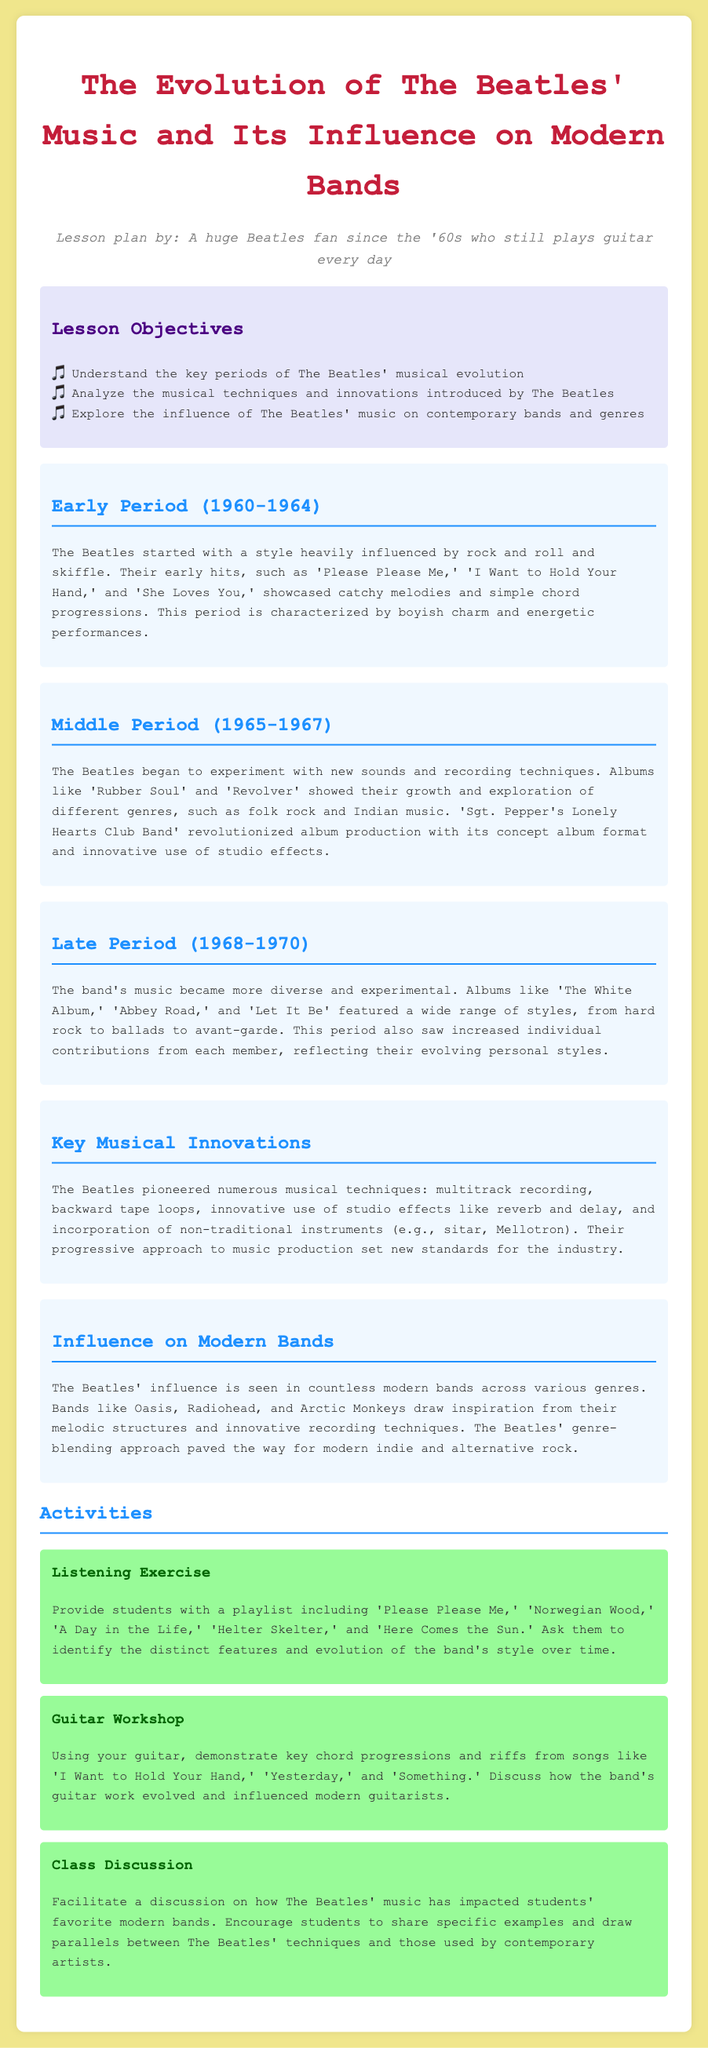what are the key periods of The Beatles' musical evolution? The lesson objectives list the key periods of evolution for The Beatles' music as early, middle, and late periods, corresponding to 1960-1964, 1965-1967, and 1968-1970.
Answer: early, middle, late which album pioneered the concept album format? The document mentions 'Sgt. Pepper's Lonely Hearts Club Band' as the album that revolutionized album production with its concept album format.
Answer: Sgt. Pepper's Lonely Hearts Club Band what innovative technique did The Beatles use that impacted music production? The section on key musical innovations states that The Beatles pioneered multitrack recording among other techniques that set new standards in the industry.
Answer: multitrack recording which song represents The Beatles' early period? The document lists 'Please Please Me,' 'I Want to Hold Your Hand,' and 'She Loves You' as examples of their early hits from 1960-1964.
Answer: Please Please Me name a modern band influenced by The Beatles. The section on influence mentions bands like Oasis, Radiohead, and Arctic Monkeys as modern bands influenced by The Beatles.
Answer: Oasis in what year did The Beatles begin their middle period? The document specifies the years for the middle period of The Beatles as 1965-1967, indicating 1965 as the starting year.
Answer: 1965 what type of activity is included that involves listening? The document mentions a listening exercise in the activities section where students listen to a playlist and identify features of The Beatles' style.
Answer: Listening Exercise which song includes a guitar workshop demonstration? The guitar workshop activity discusses demonstrating key chord progressions and riffs from songs, specifically mentioning 'I Want to Hold Your Hand,' 'Yesterday,' and 'Something.'
Answer: I Want to Hold Your Hand how many periods are outlined in The Beatles' evolution? The document explicitly divides The Beatles' evolution into three distinct periods: early, middle, and late.
Answer: three 